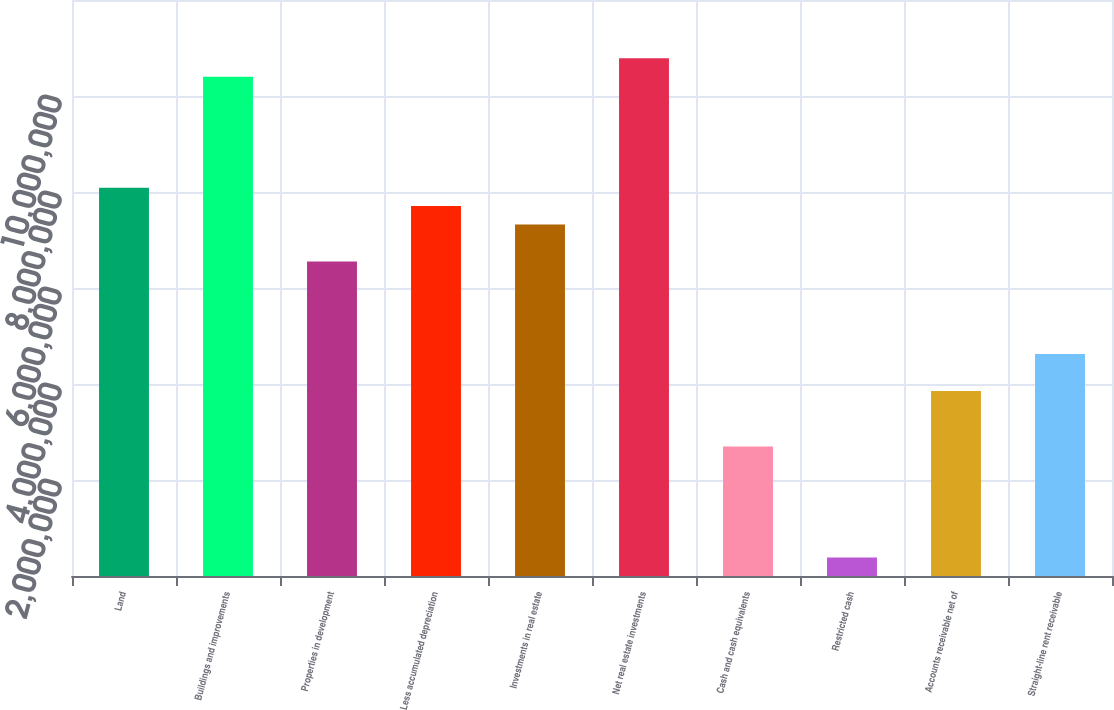Convert chart. <chart><loc_0><loc_0><loc_500><loc_500><bar_chart><fcel>Land<fcel>Buildings and improvements<fcel>Properties in development<fcel>Less accumulated depreciation<fcel>Investments in real estate<fcel>Net real estate investments<fcel>Cash and cash equivalents<fcel>Restricted cash<fcel>Accounts receivable net of<fcel>Straight-line rent receivable<nl><fcel>8.09099e+06<fcel>1.04024e+07<fcel>6.55007e+06<fcel>7.70576e+06<fcel>7.32053e+06<fcel>1.07876e+07<fcel>2.69777e+06<fcel>386384<fcel>3.85346e+06<fcel>4.62392e+06<nl></chart> 